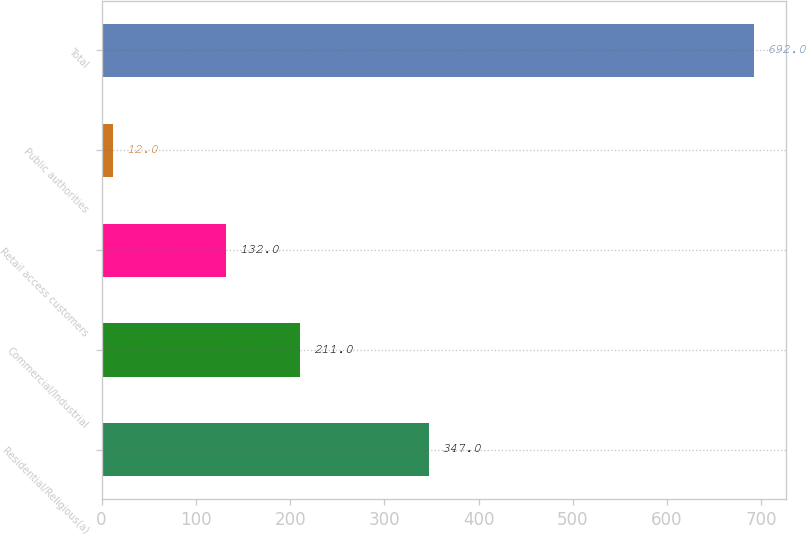<chart> <loc_0><loc_0><loc_500><loc_500><bar_chart><fcel>Residential/Religious(a)<fcel>Commercial/Industrial<fcel>Retail access customers<fcel>Public authorities<fcel>Total<nl><fcel>347<fcel>211<fcel>132<fcel>12<fcel>692<nl></chart> 